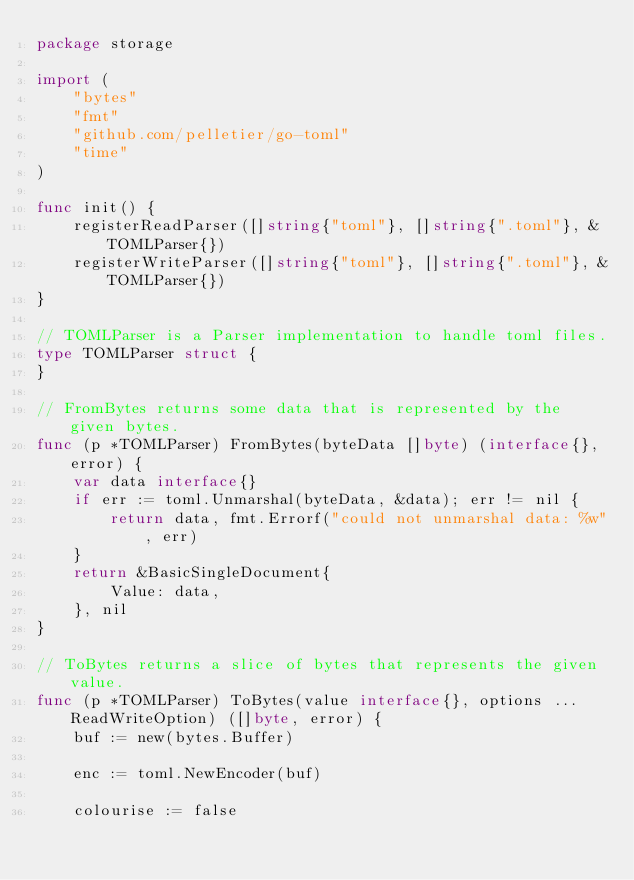<code> <loc_0><loc_0><loc_500><loc_500><_Go_>package storage

import (
	"bytes"
	"fmt"
	"github.com/pelletier/go-toml"
	"time"
)

func init() {
	registerReadParser([]string{"toml"}, []string{".toml"}, &TOMLParser{})
	registerWriteParser([]string{"toml"}, []string{".toml"}, &TOMLParser{})
}

// TOMLParser is a Parser implementation to handle toml files.
type TOMLParser struct {
}

// FromBytes returns some data that is represented by the given bytes.
func (p *TOMLParser) FromBytes(byteData []byte) (interface{}, error) {
	var data interface{}
	if err := toml.Unmarshal(byteData, &data); err != nil {
		return data, fmt.Errorf("could not unmarshal data: %w", err)
	}
	return &BasicSingleDocument{
		Value: data,
	}, nil
}

// ToBytes returns a slice of bytes that represents the given value.
func (p *TOMLParser) ToBytes(value interface{}, options ...ReadWriteOption) ([]byte, error) {
	buf := new(bytes.Buffer)

	enc := toml.NewEncoder(buf)

	colourise := false
</code> 